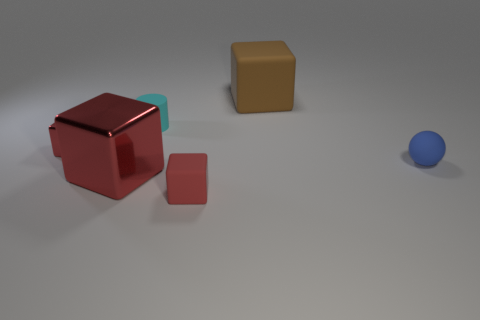Subtract all cyan spheres. How many red cubes are left? 3 Subtract all red blocks. How many blocks are left? 1 Add 2 small red matte cylinders. How many objects exist? 8 Subtract all gray blocks. Subtract all red spheres. How many blocks are left? 4 Subtract all spheres. How many objects are left? 5 Subtract all green things. Subtract all tiny matte blocks. How many objects are left? 5 Add 3 small matte objects. How many small matte objects are left? 6 Add 3 matte things. How many matte things exist? 7 Subtract 0 gray cubes. How many objects are left? 6 